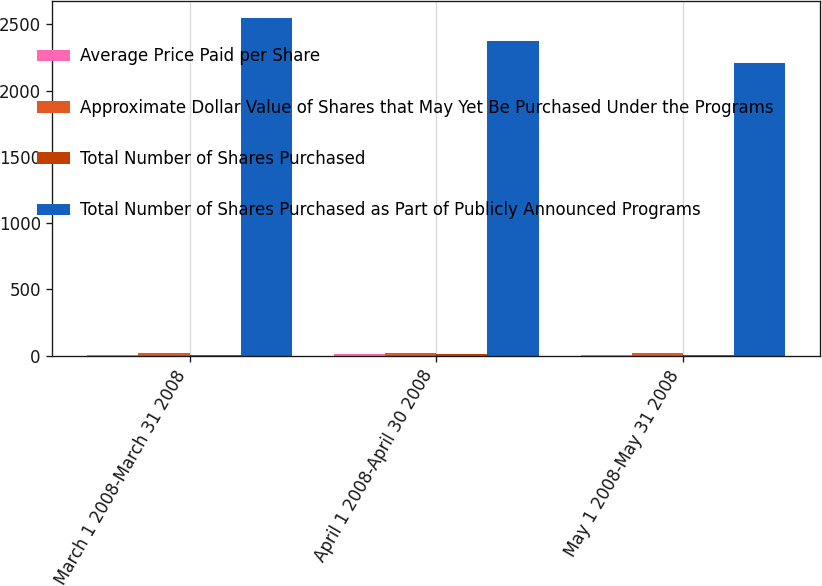<chart> <loc_0><loc_0><loc_500><loc_500><stacked_bar_chart><ecel><fcel>March 1 2008-March 31 2008<fcel>April 1 2008-April 30 2008<fcel>May 1 2008-May 31 2008<nl><fcel>Average Price Paid per Share<fcel>8.1<fcel>8.4<fcel>7.6<nl><fcel>Approximate Dollar Value of Shares that May Yet Be Purchased Under the Programs<fcel>19.63<fcel>20.87<fcel>21.89<nl><fcel>Total Number of Shares Purchased<fcel>8.1<fcel>8.4<fcel>7.6<nl><fcel>Total Number of Shares Purchased as Part of Publicly Announced Programs<fcel>2550.8<fcel>2376.1<fcel>2209.4<nl></chart> 